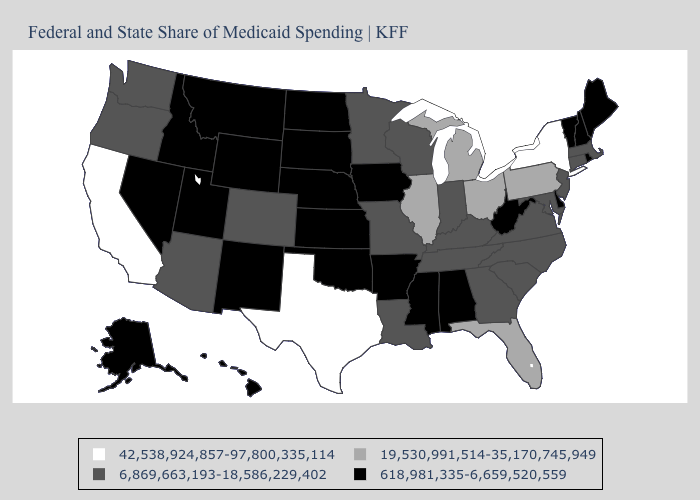What is the value of Minnesota?
Be succinct. 6,869,663,193-18,586,229,402. What is the lowest value in the MidWest?
Be succinct. 618,981,335-6,659,520,559. Name the states that have a value in the range 6,869,663,193-18,586,229,402?
Keep it brief. Arizona, Colorado, Connecticut, Georgia, Indiana, Kentucky, Louisiana, Maryland, Massachusetts, Minnesota, Missouri, New Jersey, North Carolina, Oregon, South Carolina, Tennessee, Virginia, Washington, Wisconsin. Among the states that border Georgia , does North Carolina have the lowest value?
Quick response, please. No. What is the value of California?
Answer briefly. 42,538,924,857-97,800,335,114. Is the legend a continuous bar?
Answer briefly. No. Name the states that have a value in the range 42,538,924,857-97,800,335,114?
Short answer required. California, New York, Texas. Does the map have missing data?
Be succinct. No. What is the value of Texas?
Keep it brief. 42,538,924,857-97,800,335,114. What is the value of Maryland?
Quick response, please. 6,869,663,193-18,586,229,402. Does Delaware have the same value as Georgia?
Concise answer only. No. Which states have the highest value in the USA?
Be succinct. California, New York, Texas. Does Vermont have the lowest value in the USA?
Keep it brief. Yes. What is the value of North Carolina?
Write a very short answer. 6,869,663,193-18,586,229,402. Does Texas have the highest value in the USA?
Keep it brief. Yes. 